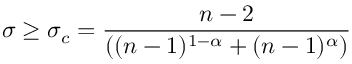Convert formula to latex. <formula><loc_0><loc_0><loc_500><loc_500>\sigma \geq \sigma _ { c } = \frac { n - 2 } { ( ( n - 1 ) ^ { 1 - \alpha } + ( n - 1 ) ^ { \alpha } ) }</formula> 